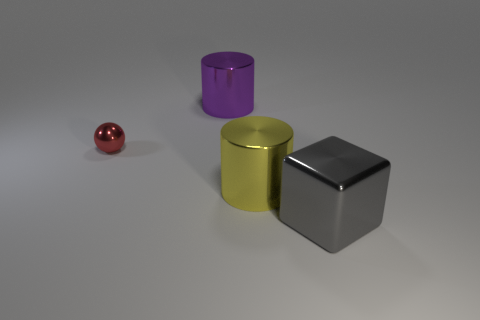Are there any other things that are the same size as the red shiny thing?
Your response must be concise. No. Are there any things?
Provide a succinct answer. Yes. What is the shape of the big metal thing that is both on the left side of the big gray object and in front of the tiny red object?
Make the answer very short. Cylinder. What is the size of the shiny cylinder that is in front of the purple metal cylinder?
Your answer should be very brief. Large. Do the shiny cylinder that is to the left of the yellow thing and the tiny ball have the same color?
Your answer should be compact. No. What number of red metallic objects are the same shape as the big gray object?
Offer a very short reply. 0. How many things are cylinders that are in front of the purple thing or large cylinders behind the ball?
Provide a short and direct response. 2. How many cyan objects are big cylinders or shiny blocks?
Give a very brief answer. 0. What is the material of the object that is both behind the yellow shiny object and right of the red object?
Provide a succinct answer. Metal. Are the large purple thing and the big gray block made of the same material?
Offer a very short reply. Yes. 